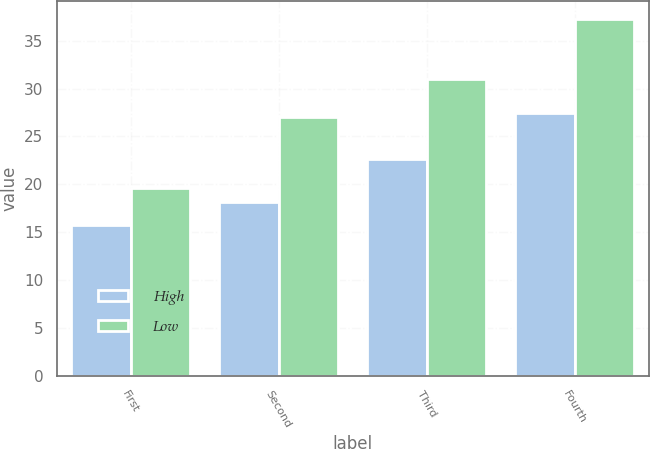<chart> <loc_0><loc_0><loc_500><loc_500><stacked_bar_chart><ecel><fcel>First<fcel>Second<fcel>Third<fcel>Fourth<nl><fcel>High<fcel>15.71<fcel>18.11<fcel>22.66<fcel>27.46<nl><fcel>Low<fcel>19.63<fcel>27<fcel>31<fcel>37.25<nl></chart> 